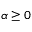Convert formula to latex. <formula><loc_0><loc_0><loc_500><loc_500>\alpha \geq 0</formula> 